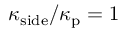Convert formula to latex. <formula><loc_0><loc_0><loc_500><loc_500>\kappa _ { s i d e } / \kappa _ { p } = 1</formula> 